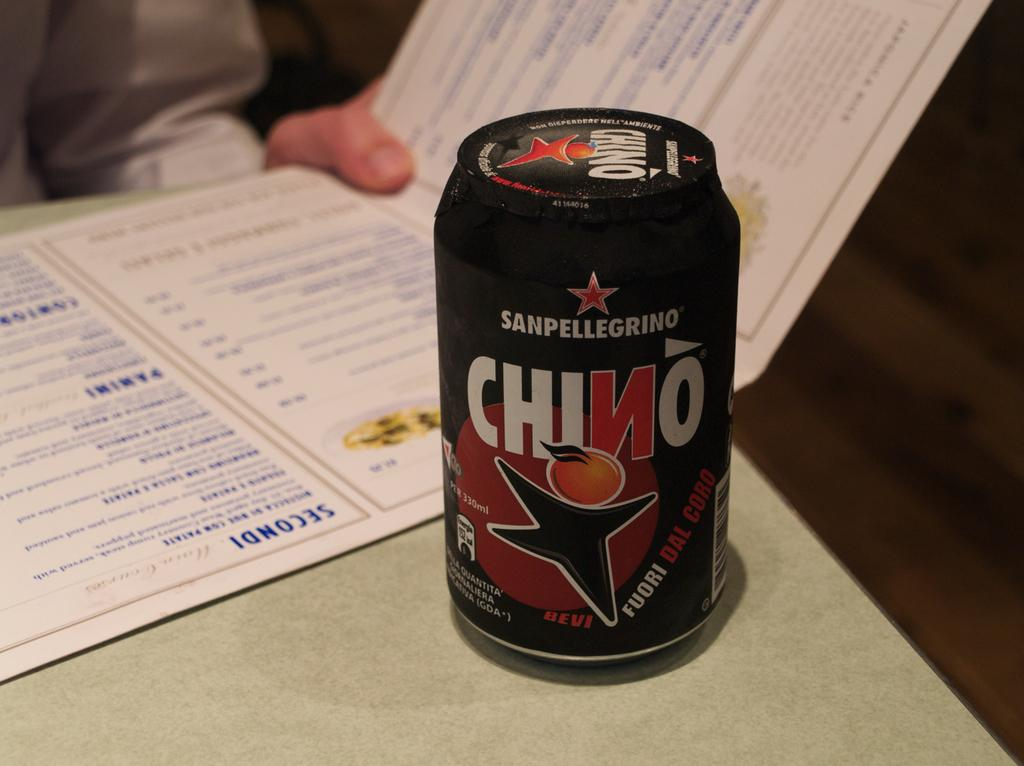<image>
Relay a brief, clear account of the picture shown. The can of SanPelligrino has not yet been opened. 